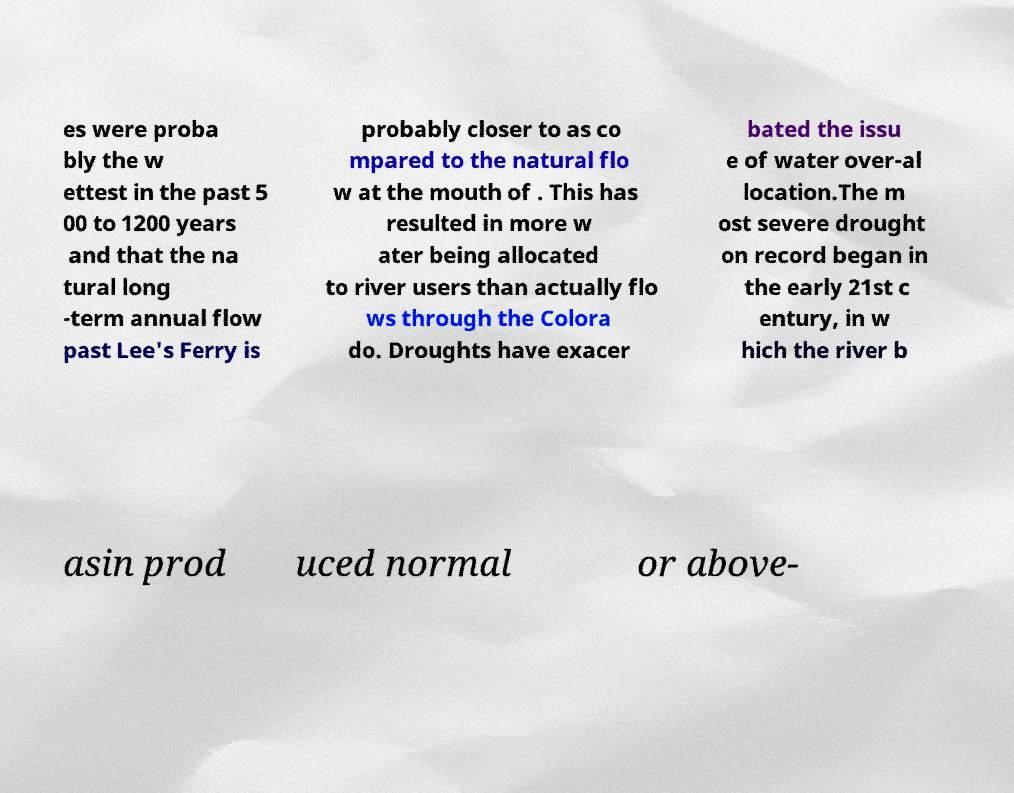For documentation purposes, I need the text within this image transcribed. Could you provide that? es were proba bly the w ettest in the past 5 00 to 1200 years and that the na tural long -term annual flow past Lee's Ferry is probably closer to as co mpared to the natural flo w at the mouth of . This has resulted in more w ater being allocated to river users than actually flo ws through the Colora do. Droughts have exacer bated the issu e of water over-al location.The m ost severe drought on record began in the early 21st c entury, in w hich the river b asin prod uced normal or above- 